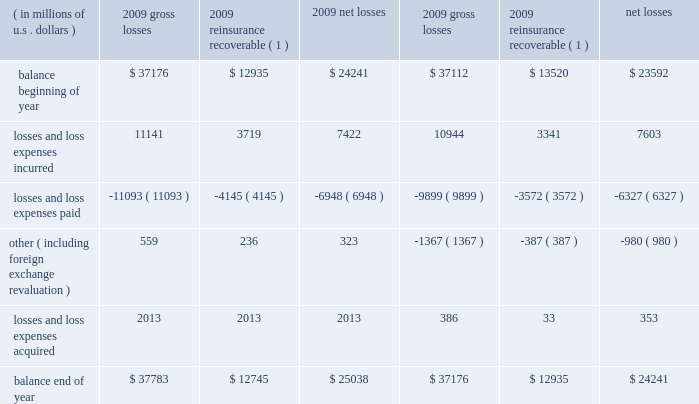Critical accounting estimates our consolidated financial statements include amounts that , either by their nature or due to requirements of accounting princi- ples generally accepted in the u.s .
( gaap ) , are determined using best estimates and assumptions .
While we believe that the amounts included in our consolidated financial statements reflect our best judgment , actual amounts could ultimately materi- ally differ from those currently presented .
We believe the items that require the most subjective and complex estimates are : 2022 unpaid loss and loss expense reserves , including long-tail asbestos and environmental ( a&e ) reserves ; 2022 future policy benefits reserves ; 2022 valuation of value of business acquired ( voba ) and amortization of deferred policy acquisition costs and voba ; 2022 the assessment of risk transfer for certain structured insurance and reinsurance contracts ; 2022 reinsurance recoverable , including a provision for uncollectible reinsurance ; 2022 the valuation of our investment portfolio and assessment of other-than-temporary impairments ( otti ) ; 2022 the valuation of deferred tax assets ; 2022 the valuation of derivative instruments related to guaranteed minimum income benefits ( gmib ) ; and 2022 the valuation of goodwill .
We believe our accounting policies for these items are of critical importance to our consolidated financial statements .
The following discussion provides more information regarding the estimates and assumptions required to arrive at these amounts and should be read in conjunction with the sections entitled : prior period development , asbestos and environmental and other run-off liabilities , reinsurance recoverable on ceded reinsurance , investments , net realized gains ( losses ) , and other income and expense items .
Unpaid losses and loss expenses overview and key data as an insurance and reinsurance company , we are required , by applicable laws and regulations and gaap , to establish loss and loss expense reserves for the estimated unpaid portion of the ultimate liability for losses and loss expenses under the terms of our policies and agreements with our insured and reinsured customers .
The estimate of the liabilities includes provisions for claims that have been reported but are unpaid at the balance sheet date ( case reserves ) and for future obligations on claims that have been incurred but not reported ( ibnr ) at the balance sheet date ( ibnr may also include a provision for additional development on reported claims in instances where the case reserve is viewed to be potentially insufficient ) .
Loss reserves also include an estimate of expenses associated with processing and settling unpaid claims ( loss expenses ) .
At december 31 , 2009 , our gross unpaid loss and loss expense reserves were $ 37.8 billion and our net unpaid loss and loss expense reserves were $ 25 billion .
With the exception of certain structured settlements , for which the timing and amount of future claim pay- ments are reliably determinable , our loss reserves are not discounted for the time value of money .
In connection with such structured settlements , we carry net reserves of $ 76 million , net of discount .
The table below presents a roll-forward of our unpaid losses and loss expenses for the years ended december 31 , 2009 and 2008. .
( 1 ) net of provision for uncollectible reinsurance .
What is the percentage change in gross unpaid losses from 2008 to 2009? 
Computations: ((37783 - 37176) / 37176)
Answer: 0.01633. 